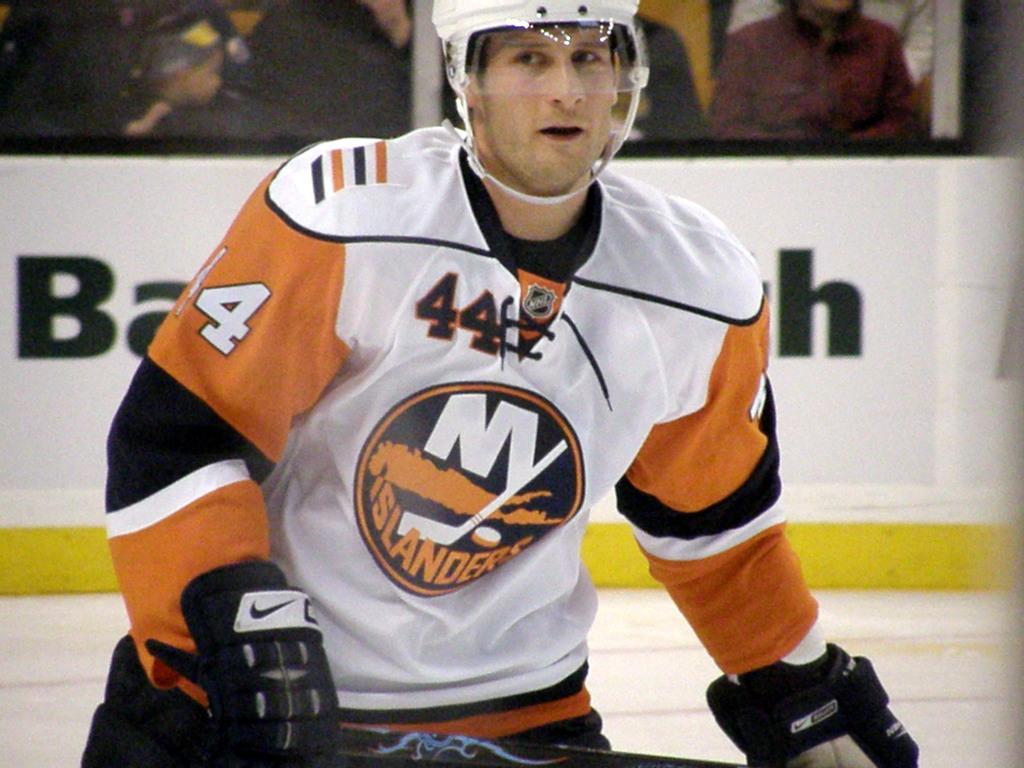In one or two sentences, can you explain what this image depicts? In this image there is a person holding an object, there is a white background behind the person, there are audience sitting. 